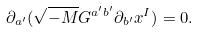<formula> <loc_0><loc_0><loc_500><loc_500>\partial _ { a ^ { \prime } } ( \sqrt { - M } G ^ { a ^ { \prime } b ^ { \prime } } \partial _ { b ^ { \prime } } x ^ { I } ) = 0 .</formula> 